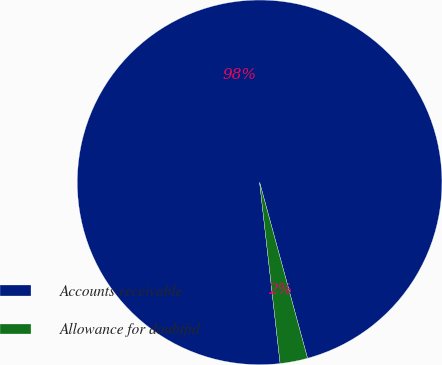Convert chart. <chart><loc_0><loc_0><loc_500><loc_500><pie_chart><fcel>Accounts receivable<fcel>Allowance for doubtful<nl><fcel>97.56%<fcel>2.44%<nl></chart> 